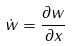<formula> <loc_0><loc_0><loc_500><loc_500>\dot { w } = \frac { \partial w } { \partial x }</formula> 